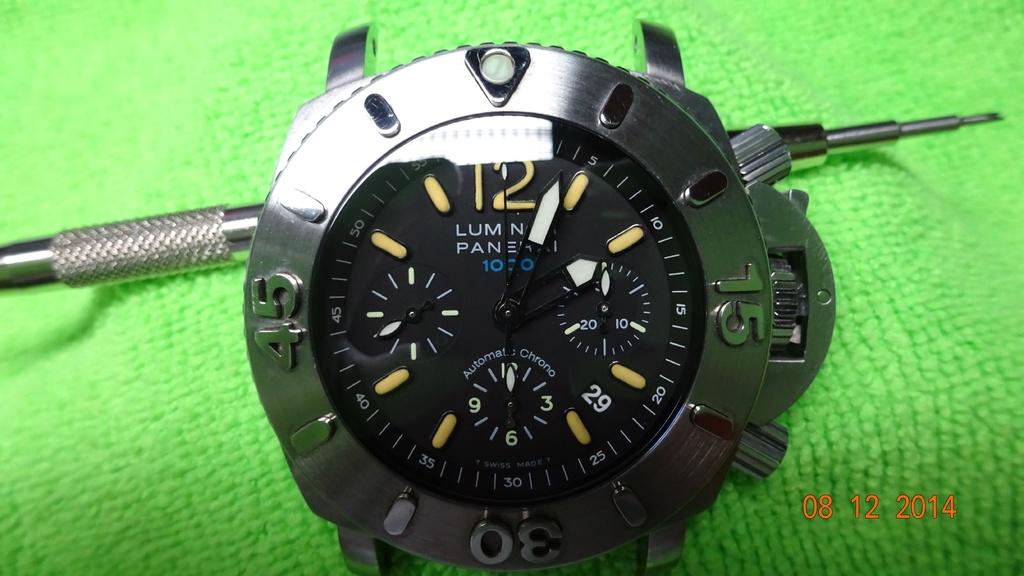What time is it?
Make the answer very short. 2:04. What is automatic?
Your answer should be compact. Chrono. 